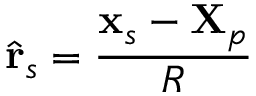Convert formula to latex. <formula><loc_0><loc_0><loc_500><loc_500>\hat { r } _ { s } = \frac { x _ { s } - X _ { p } } { R }</formula> 